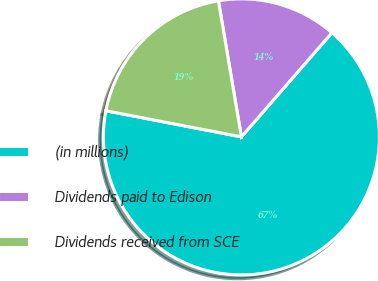<chart> <loc_0><loc_0><loc_500><loc_500><pie_chart><fcel>(in millions)<fcel>Dividends paid to Edison<fcel>Dividends received from SCE<nl><fcel>66.65%<fcel>14.05%<fcel>19.31%<nl></chart> 